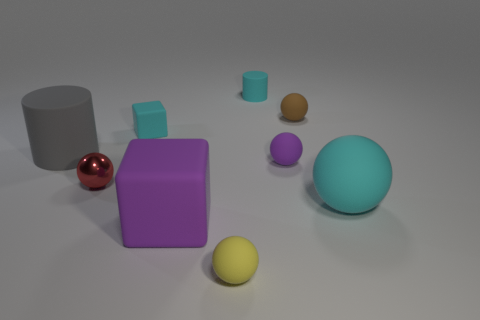What number of spheres are large cyan metal objects or tiny yellow matte things?
Offer a very short reply. 1. There is a cyan thing to the right of the tiny cyan cylinder; what is its material?
Provide a short and direct response. Rubber. Is the number of cyan matte cubes less than the number of large yellow matte cylinders?
Provide a short and direct response. No. There is a matte object that is both to the left of the large purple block and in front of the small block; how big is it?
Provide a short and direct response. Large. What size is the rubber thing that is left of the small red ball that is in front of the tiny brown rubber thing that is on the left side of the cyan matte ball?
Give a very brief answer. Large. What number of other things are there of the same color as the tiny metallic ball?
Provide a succinct answer. 0. There is a cube that is to the left of the large block; is its color the same as the small shiny ball?
Your response must be concise. No. What number of things are tiny rubber objects or yellow cylinders?
Offer a terse response. 5. The matte cylinder that is on the right side of the red shiny object is what color?
Provide a short and direct response. Cyan. Are there fewer purple blocks behind the brown thing than small gray cubes?
Make the answer very short. No. 